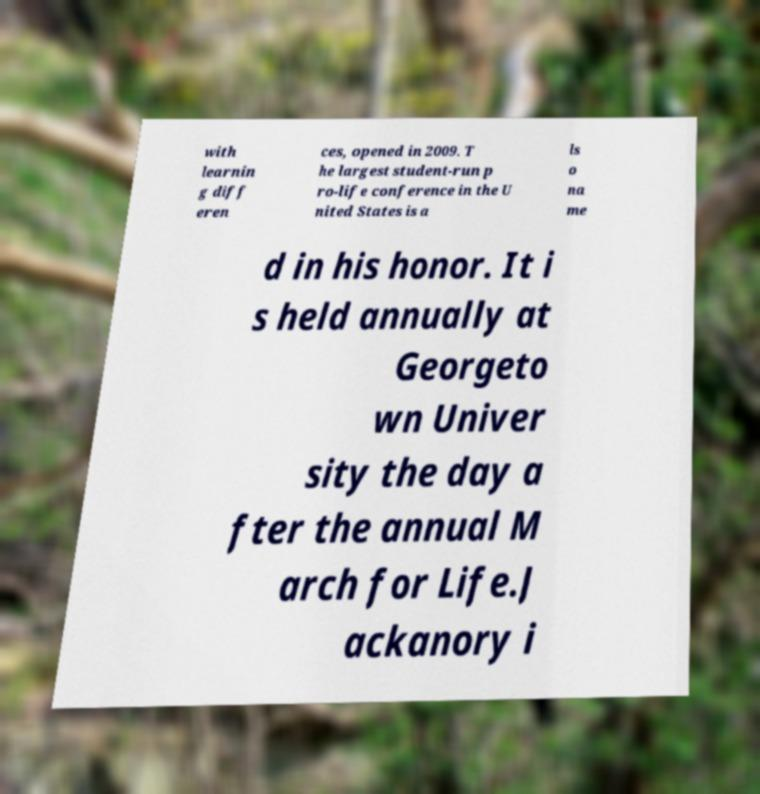What messages or text are displayed in this image? I need them in a readable, typed format. with learnin g diff eren ces, opened in 2009. T he largest student-run p ro-life conference in the U nited States is a ls o na me d in his honor. It i s held annually at Georgeto wn Univer sity the day a fter the annual M arch for Life.J ackanory i 